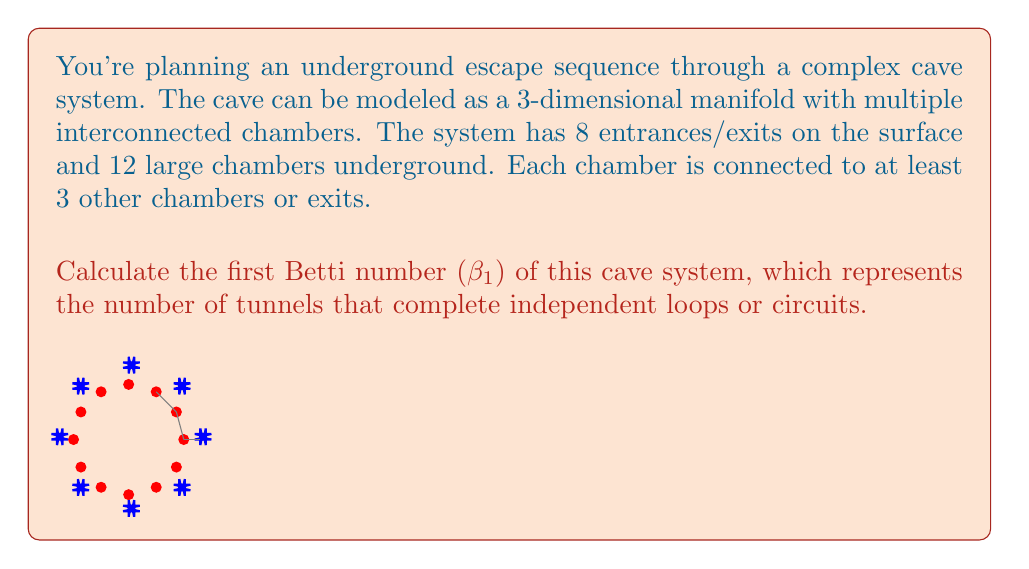Provide a solution to this math problem. To find the first Betti number (β₁) of this cave system, we need to use the Euler characteristic formula and some basic concepts from algebraic topology:

1) First, let's define our components:
   - Vertices (V): 20 (12 chambers + 8 exits)
   - Edges (E): We don't know the exact number, but we can calculate it
   - Faces (F): 0 (we're dealing with a network of tunnels, not enclosed surfaces)

2) The Euler characteristic (χ) for a 3D manifold is given by:
   $$χ = V - E + F$$

3) For a connected 3D manifold, the Euler characteristic is related to the Betti numbers by:
   $$χ = 1 - β₁ + β₂$$

4) In our case, β₂ = 0 (no enclosed voids), so:
   $$χ = 1 - β₁$$

5) To find E, we use the fact that each chamber is connected to at least 3 others. The minimum total number of connections is:
   $$(12 * 3) / 2 = 18$$ (divided by 2 to avoid double-counting)

6) Adding the 8 connections to the exits:
   $$E = 18 + 8 = 26$$

7) Now we can calculate χ:
   $$χ = V - E + F = 20 - 26 + 0 = -6$$

8) Using the relation from step 4:
   $$-6 = 1 - β₁$$
   $$β₁ = 7$$

Therefore, the first Betti number of this cave system is 7, meaning there are 7 independent loops or circuits in the tunnel network.
Answer: 7 